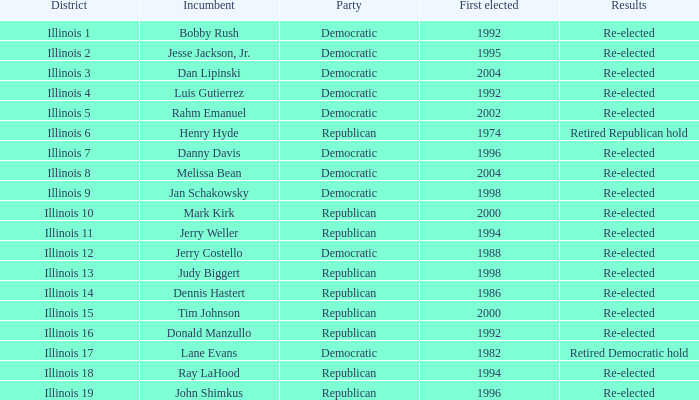What is re-elected Incumbent Jerry Costello's First elected date? 1988.0. 